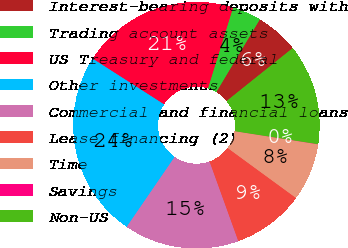Convert chart to OTSL. <chart><loc_0><loc_0><loc_500><loc_500><pie_chart><fcel>Interest-bearing deposits with<fcel>Trading account assets<fcel>US Treasury and federal<fcel>Other investments<fcel>Commercial and financial loans<fcel>Lease financing (2)<fcel>Time<fcel>Savings<fcel>Non-US<nl><fcel>5.67%<fcel>3.79%<fcel>20.73%<fcel>24.5%<fcel>15.08%<fcel>9.44%<fcel>7.56%<fcel>0.03%<fcel>13.2%<nl></chart> 